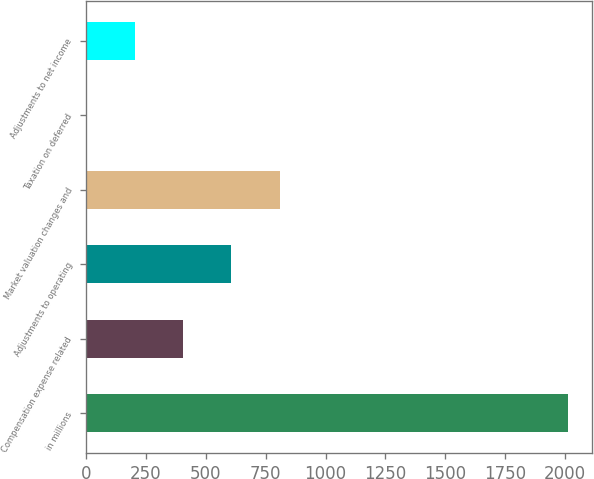<chart> <loc_0><loc_0><loc_500><loc_500><bar_chart><fcel>in millions<fcel>Compensation expense related<fcel>Adjustments to operating<fcel>Market valuation changes and<fcel>Taxation on deferred<fcel>Adjustments to net income<nl><fcel>2013<fcel>406.44<fcel>607.26<fcel>808.08<fcel>4.8<fcel>205.62<nl></chart> 